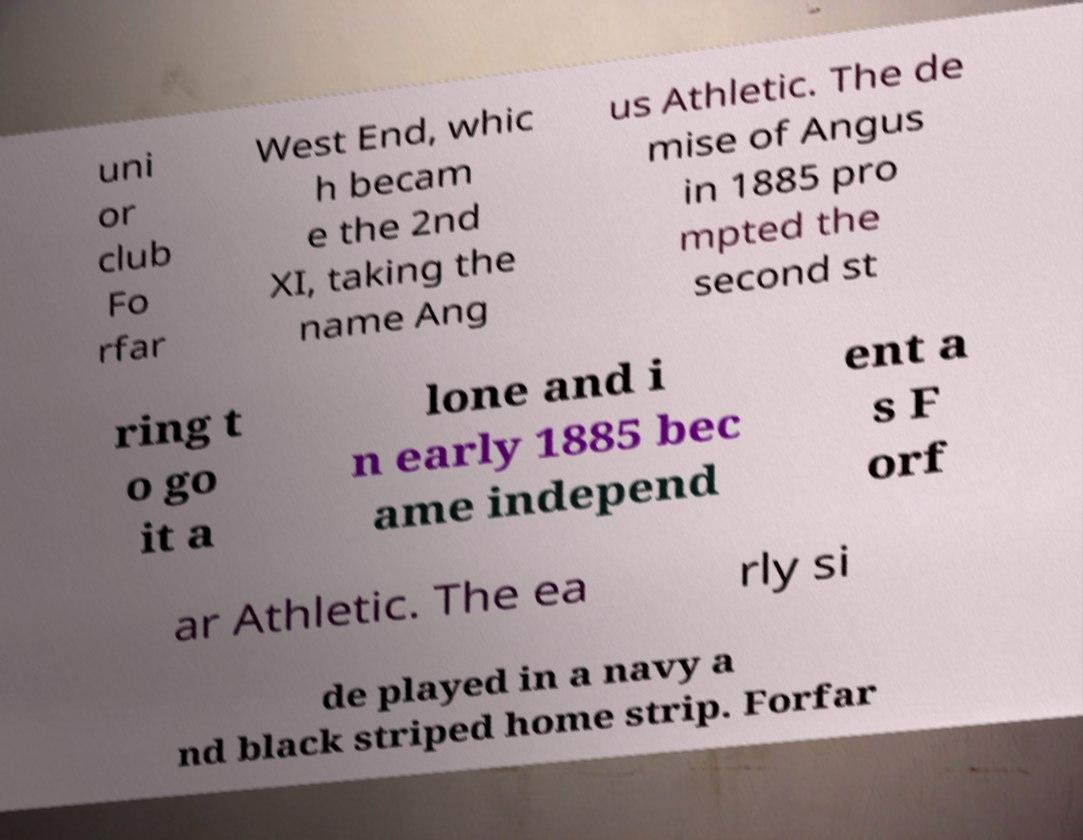Can you read and provide the text displayed in the image?This photo seems to have some interesting text. Can you extract and type it out for me? uni or club Fo rfar West End, whic h becam e the 2nd XI, taking the name Ang us Athletic. The de mise of Angus in 1885 pro mpted the second st ring t o go it a lone and i n early 1885 bec ame independ ent a s F orf ar Athletic. The ea rly si de played in a navy a nd black striped home strip. Forfar 